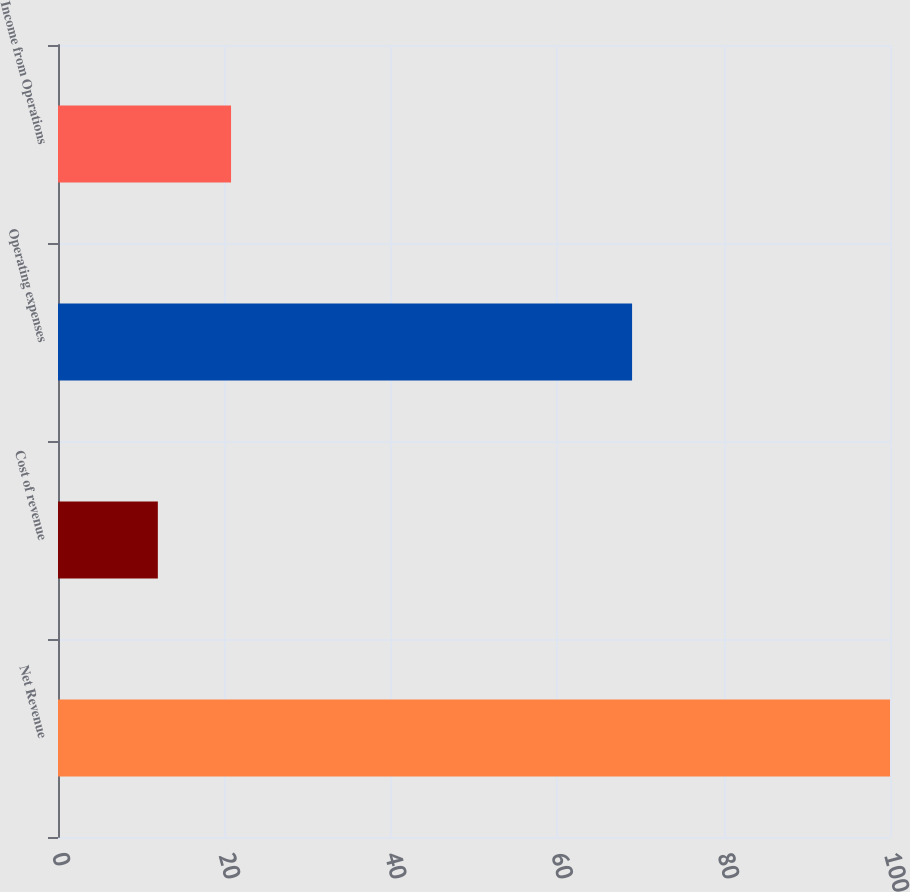Convert chart. <chart><loc_0><loc_0><loc_500><loc_500><bar_chart><fcel>Net Revenue<fcel>Cost of revenue<fcel>Operating expenses<fcel>Income from Operations<nl><fcel>100<fcel>12<fcel>69<fcel>20.8<nl></chart> 